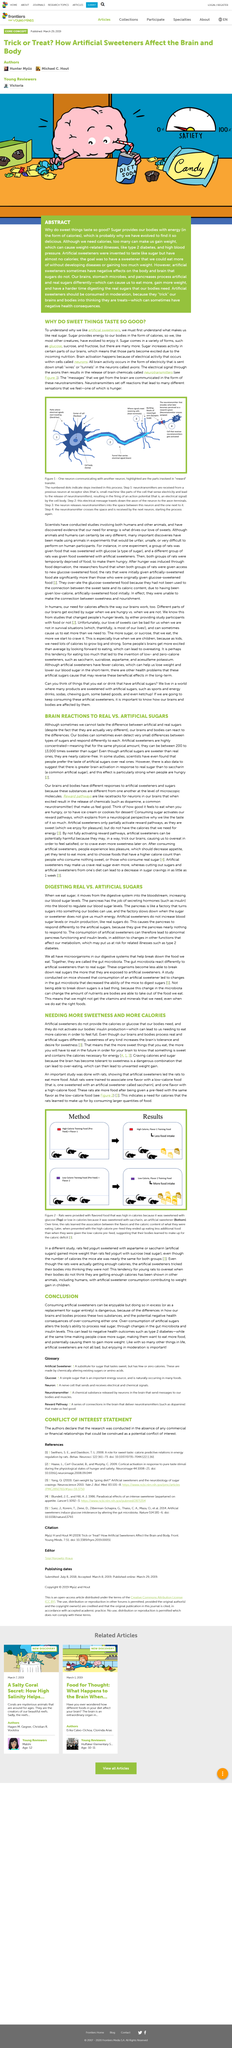Outline some significant characteristics in this image. Artificial sweeteners do not provide the calories or glucose that our bodies need. Excessive consumption of artificial sugars can lead to a range of negative health outcomes, including the development of Type 2 diabetes. Artificial sweeteners can be up to 13,000 times sweeter than sugar, making them a popular alternative for those looking to reduce their calorie intake without sacrificing taste. Sugar comes in various forms, including glucose, sucrose, and fructose, and more. Artificial sugars, unlike real sugars, are nearly calorie-free. 